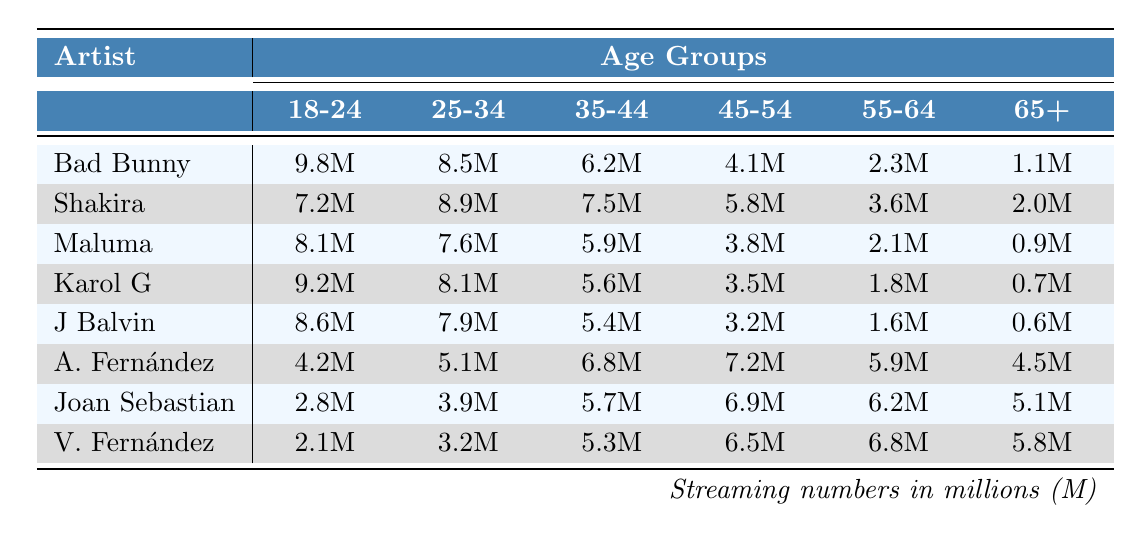What is the total number of streams for Bad Bunny among all age groups? For Bad Bunny, the streaming numbers across all age groups are: 9.8M (18-24) + 8.5M (25-34) + 6.2M (35-44) + 4.1M (45-54) + 2.3M (55-64) + 1.1M (65+). Adding them gives a total of 9.8 + 8.5 + 6.2 + 4.1 + 2.3 + 1.1 = 32.0 million streams.
Answer: 32.0 million Which age group has the highest streaming number for Shakira? The streaming number for Shakira in each age group is: 7.2M (18-24), 8.9M (25-34), 7.5M (35-44), 5.8M (45-54), 3.6M (55-64), and 2.0M (65+). The highest value is in the 25-34 age group with 8.9 million streams.
Answer: 25-34 Who has the lowest number of streams among the artists listed for the age group 45-54? The streaming numbers for each artist in the 45-54 age group are: 4.1M (Bad Bunny), 5.8M (Shakira), 3.8M (Maluma), 3.5M (Karol G), 3.2M (J Balvin), 7.2M (Alejandro Fernández), 6.9M (Joan Sebastian), and 6.5M (Vicente Fernández). The lowest is Maluma with 3.8 million.
Answer: Maluma What artist has the second highest streaming total for the 18-24 age group? The streaming numbers for the 18-24 age group are: 9.8M (Bad Bunny), 7.2M (Shakira), 8.1M (Maluma), 9.2M (Karol G), 8.6M (J Balvin), 4.2M (Alejandro Fernández), 2.8M (Joan Sebastian), and 2.1M (Vicente Fernández). The second highest figure is 8.6 million for J Balvin.
Answer: J Balvin If we compare the average daily listening hours for the age group 55-64 across all artists, which artist has the lowest average? For the age group 55-64, the average daily listening hours are 1.9 (Bad Bunny), 1.7 (Shakira), 1.5 (Maluma), 1.4 (Karol G), 1.1 (J Balvin), 5.9 (Alejandro Fernández), 6.2 (Joan Sebastian), and 6.8 (Vicente Fernández). The lowest value is 1.1 for J Balvin.
Answer: J Balvin What is the total number of streaming hours for Vicente Fernández in the 25-34 age group and the 35-44 age group combined? The streaming numbers for Vicente Fernández are 3.2M (25-34) and 5.3M (35-44). Adding these values gives 3.2 + 5.3 = 8.5 million.
Answer: 8.5 million Is the average daily listening hours for the 65+ age group greater than or equal to 2 hours? The average daily listening hours for the 65+ age group are 1.6 (Bad Bunny), 1.4 (Shakira), 1.2 (Maluma), 1.0 (Karol G), 0.8 (J Balvin), 4.5 (Alejandro Fernández), 5.1 (Joan Sebastian), and 5.8 (Vicente Fernández). All values are less than 2 hours, so the statement is false.
Answer: No Which age group listens the most to Alejandro Fernández? The streaming numbers for Alejandro Fernández reveal: 4.2M (18-24), 5.1M (25-34), 6.8M (35-44), 7.2M (45-54), 5.9M (55-64), and 4.5M (65+). The highest is 7.2 million in the 45-54 age group.
Answer: 45-54 What is the average streaming number for Joan Sebastian across all age groups? Joan Sebastian's streaming numbers are: 2.8M (18-24), 3.9M (25-34), 5.7M (35-44), 6.9M (45-54), 6.2M (55-64), and 5.1M (65+). Summing gives 30.6 million; dividing by 6 gives an average of 5.1 million streams.
Answer: 5.1 million Which age group had the lowest overall average daily listening hours? The average daily listening hours by age groups are: 1.6 (65+), 1.9 (55-64), 2.2 (45-54), 2.5 (35-44), 2.8 (25-34), and 3.2 (18-24). The lowest average is in the 65+ age group.
Answer: 65+ 